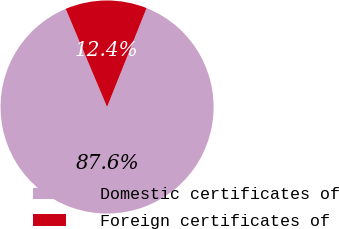Convert chart to OTSL. <chart><loc_0><loc_0><loc_500><loc_500><pie_chart><fcel>Domestic certificates of<fcel>Foreign certificates of<nl><fcel>87.6%<fcel>12.4%<nl></chart> 